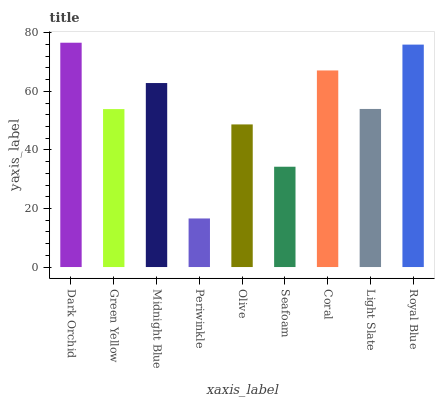Is Periwinkle the minimum?
Answer yes or no. Yes. Is Dark Orchid the maximum?
Answer yes or no. Yes. Is Green Yellow the minimum?
Answer yes or no. No. Is Green Yellow the maximum?
Answer yes or no. No. Is Dark Orchid greater than Green Yellow?
Answer yes or no. Yes. Is Green Yellow less than Dark Orchid?
Answer yes or no. Yes. Is Green Yellow greater than Dark Orchid?
Answer yes or no. No. Is Dark Orchid less than Green Yellow?
Answer yes or no. No. Is Light Slate the high median?
Answer yes or no. Yes. Is Light Slate the low median?
Answer yes or no. Yes. Is Seafoam the high median?
Answer yes or no. No. Is Dark Orchid the low median?
Answer yes or no. No. 